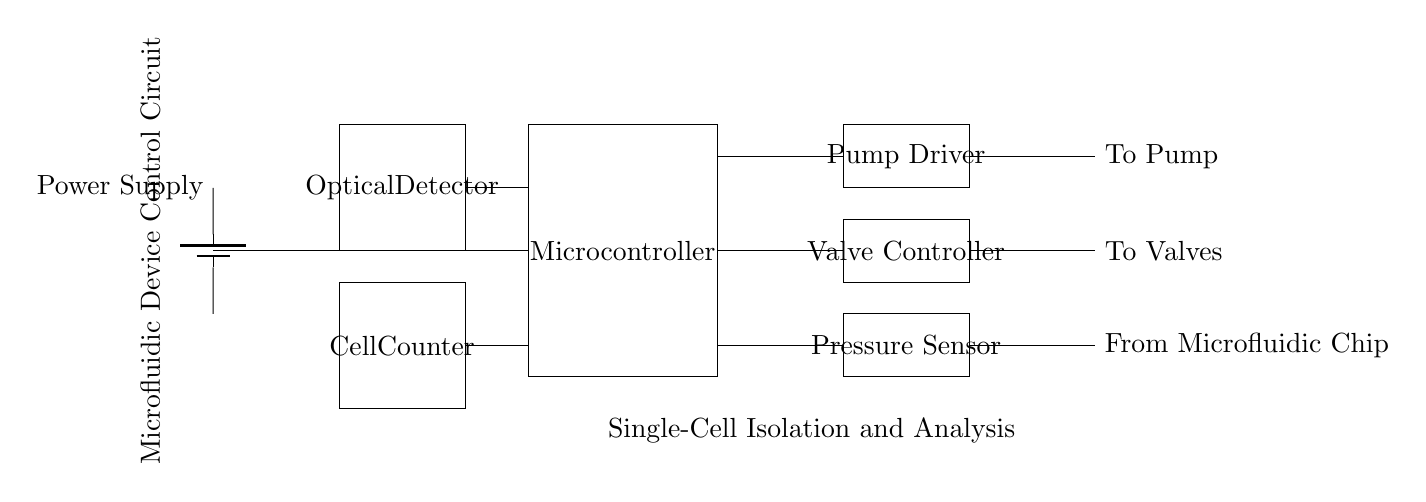What component supplies power to the circuit? The power supply is represented by the battery symbol on the left side of the circuit diagram, indicating it is the source of electrical energy for the entire microfluidic control circuit.
Answer: Power Supply What does the microcontroller connect to? The microcontroller connects directly to the pump driver, valve controller, pressure sensor, optical detector, and cell counter, as seen by the lines extending from its output to each of those components.
Answer: Pump Driver, Valve Controller, Pressure Sensor, Optical Detector, Cell Counter Which component is responsible for detecting cells? The cell counter component, located at the bottom left, is responsible for detecting and counting cells in the microfluidic system.
Answer: Cell Counter How many main control components are shown in the circuit? The main control components include the microcontroller, pump driver, valve controller, pressure sensor, optical detector, and cell counter, totaling six significant control components in the diagram.
Answer: Six What is the function of the pump driver in the circuit? The pump driver controls the operation of the pump, which is crucial for moving fluids through the microfluidic device, as indicated by its connections showing direct control over the pump.
Answer: To control the pump What is the relationship between the pressure sensor and the microfluidic chip? The circuit shows that the pressure sensor receives input from the microfluidic chip, allowing it to measure the pressure within the device, which is critical for accurate fluid control.
Answer: Receives input from the microfluidic chip 